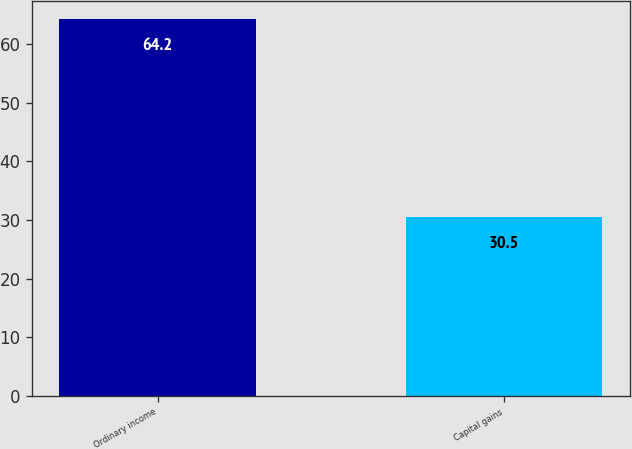Convert chart to OTSL. <chart><loc_0><loc_0><loc_500><loc_500><bar_chart><fcel>Ordinary income<fcel>Capital gains<nl><fcel>64.2<fcel>30.5<nl></chart> 